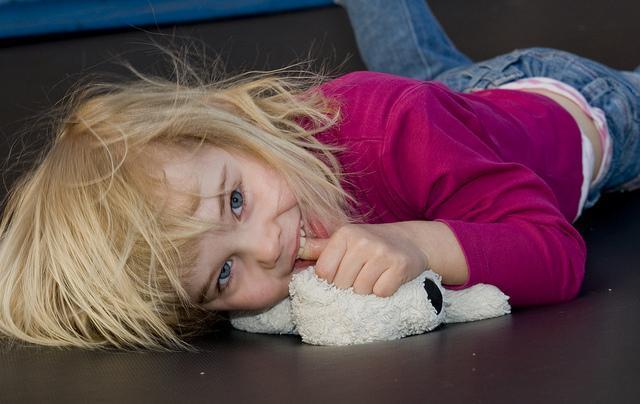Is the given caption "The teddy bear is touching the person." fitting for the image?
Answer yes or no. Yes. 